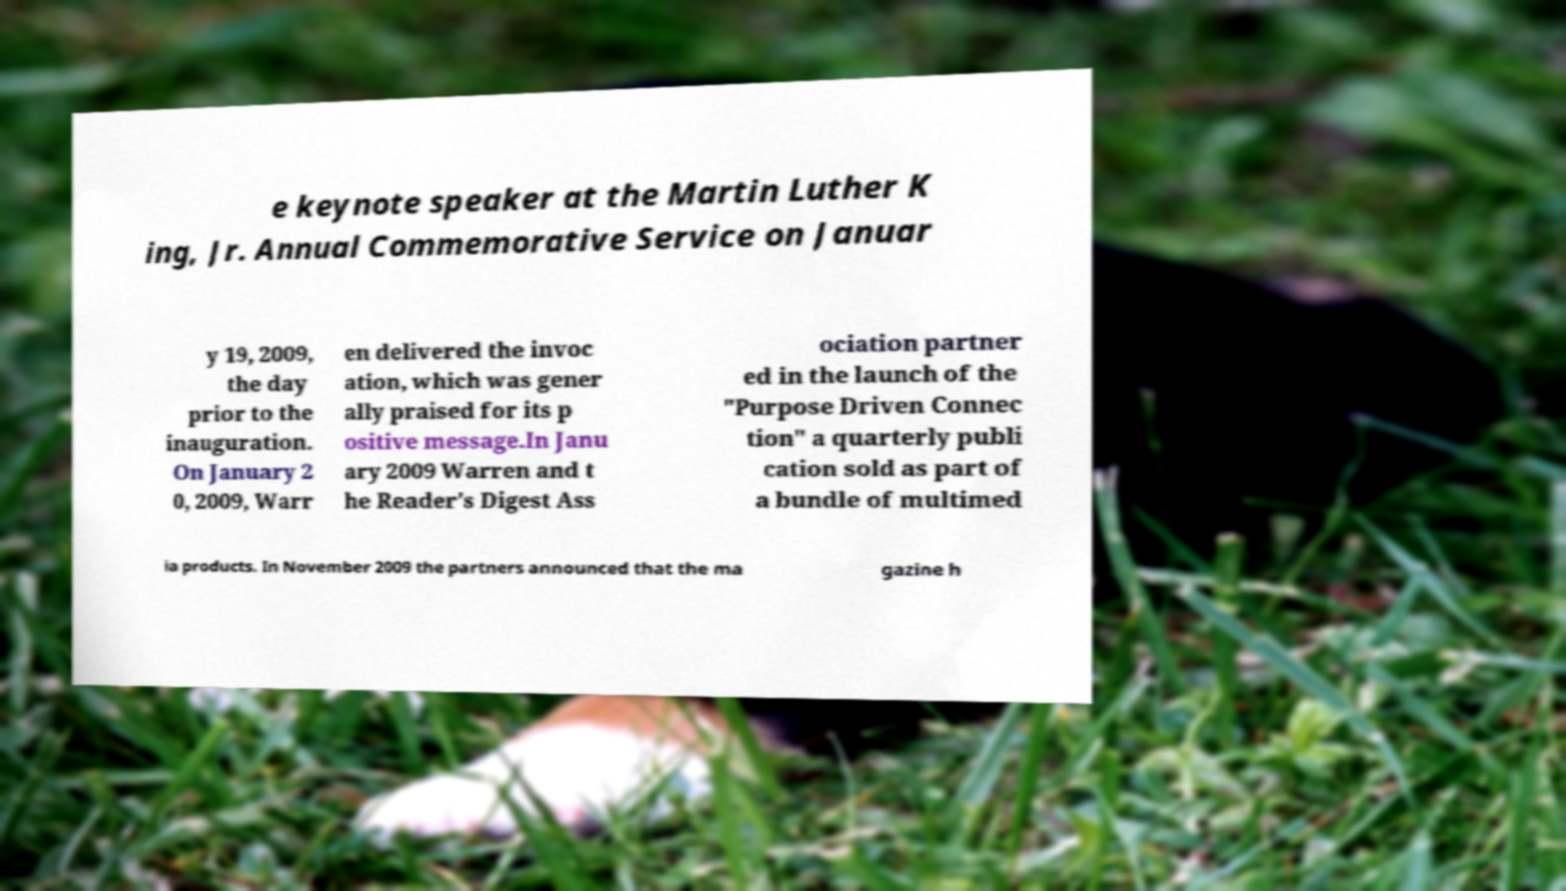For documentation purposes, I need the text within this image transcribed. Could you provide that? e keynote speaker at the Martin Luther K ing, Jr. Annual Commemorative Service on Januar y 19, 2009, the day prior to the inauguration. On January 2 0, 2009, Warr en delivered the invoc ation, which was gener ally praised for its p ositive message.In Janu ary 2009 Warren and t he Reader's Digest Ass ociation partner ed in the launch of the "Purpose Driven Connec tion" a quarterly publi cation sold as part of a bundle of multimed ia products. In November 2009 the partners announced that the ma gazine h 